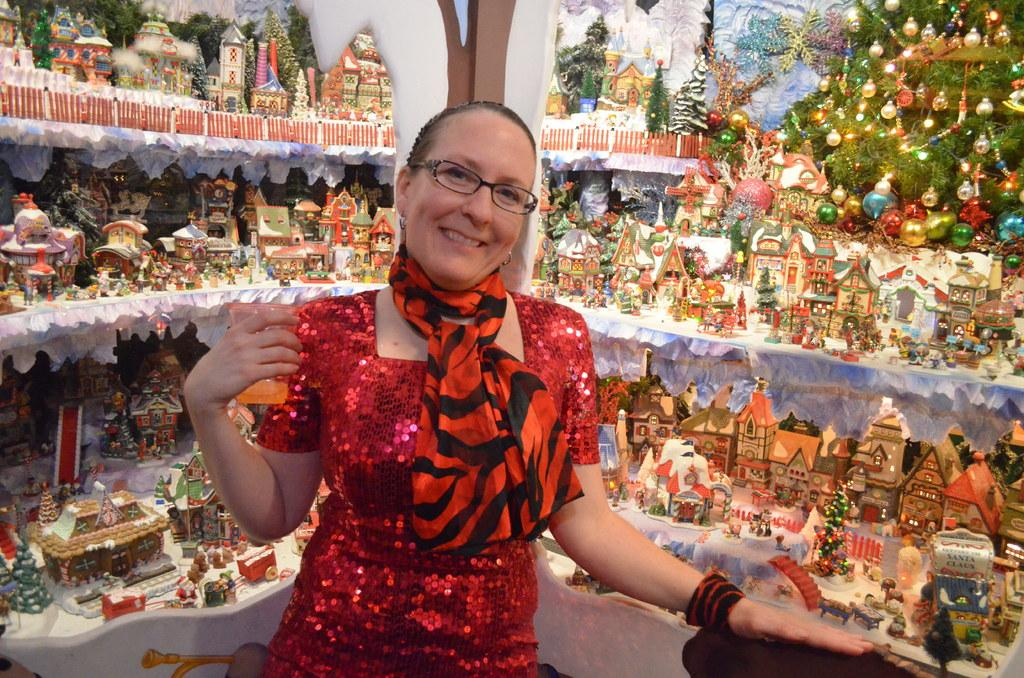What is the woman in the image doing? The woman is standing and smiling in the image. What is the woman holding in her hand? The woman is holding a glass in her hand. What can be seen in the background of the image? There are colorful toys and Christmas trees in the background of the image. How are the toys and Christmas trees arranged in the image? The toys and Christmas trees are kept in a rack in the background. Can you see a monkey playing with the toys in the image? No, there is no monkey present in the image. 